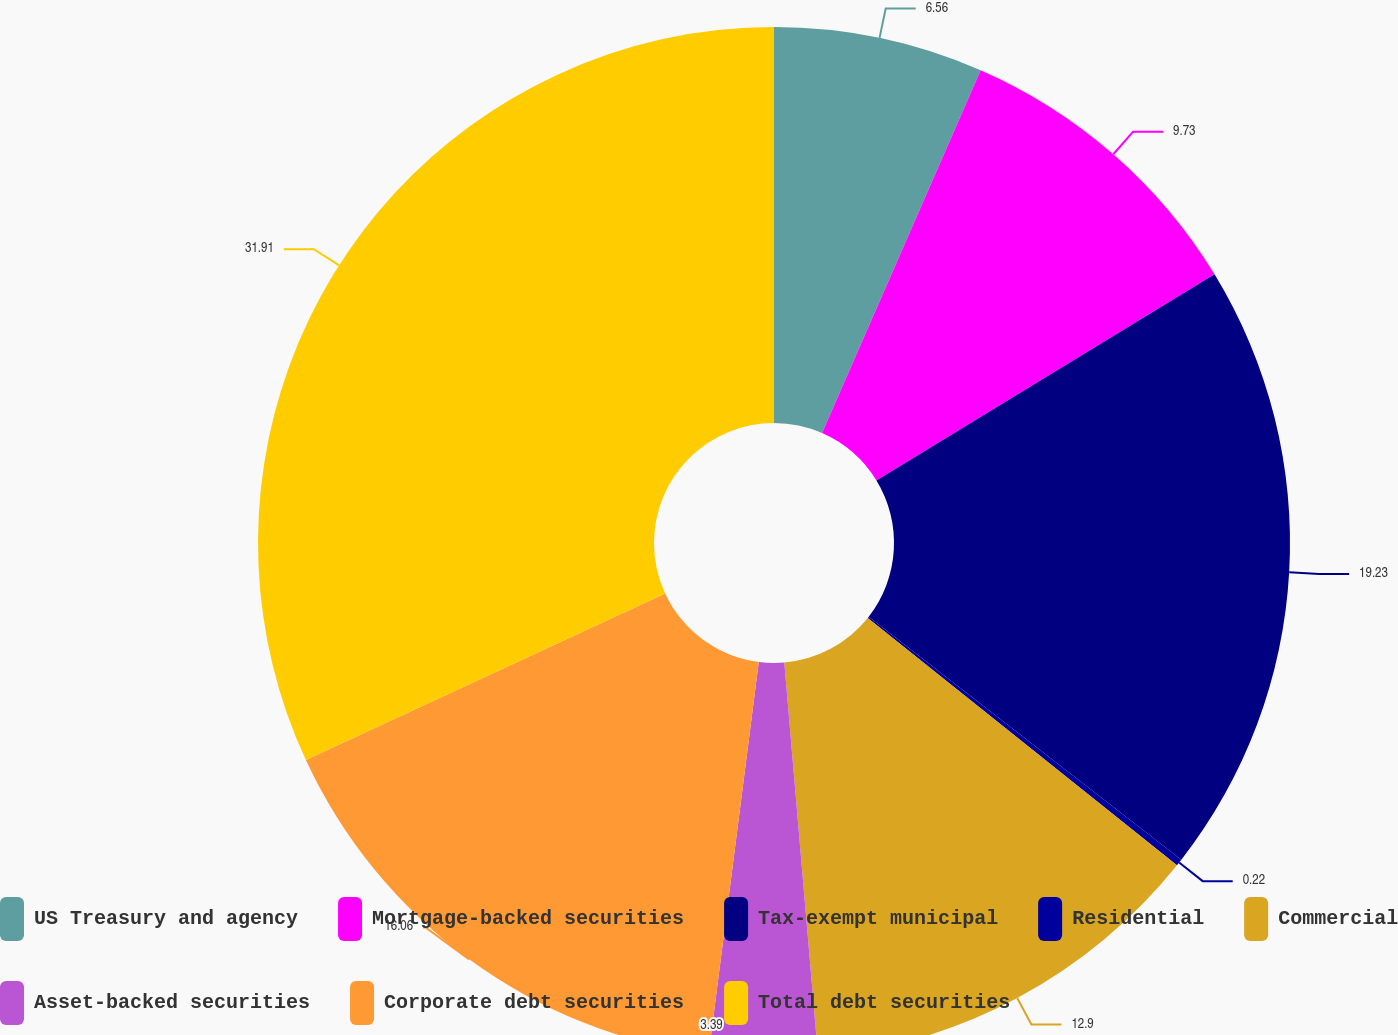<chart> <loc_0><loc_0><loc_500><loc_500><pie_chart><fcel>US Treasury and agency<fcel>Mortgage-backed securities<fcel>Tax-exempt municipal<fcel>Residential<fcel>Commercial<fcel>Asset-backed securities<fcel>Corporate debt securities<fcel>Total debt securities<nl><fcel>6.56%<fcel>9.73%<fcel>19.24%<fcel>0.22%<fcel>12.9%<fcel>3.39%<fcel>16.07%<fcel>31.92%<nl></chart> 